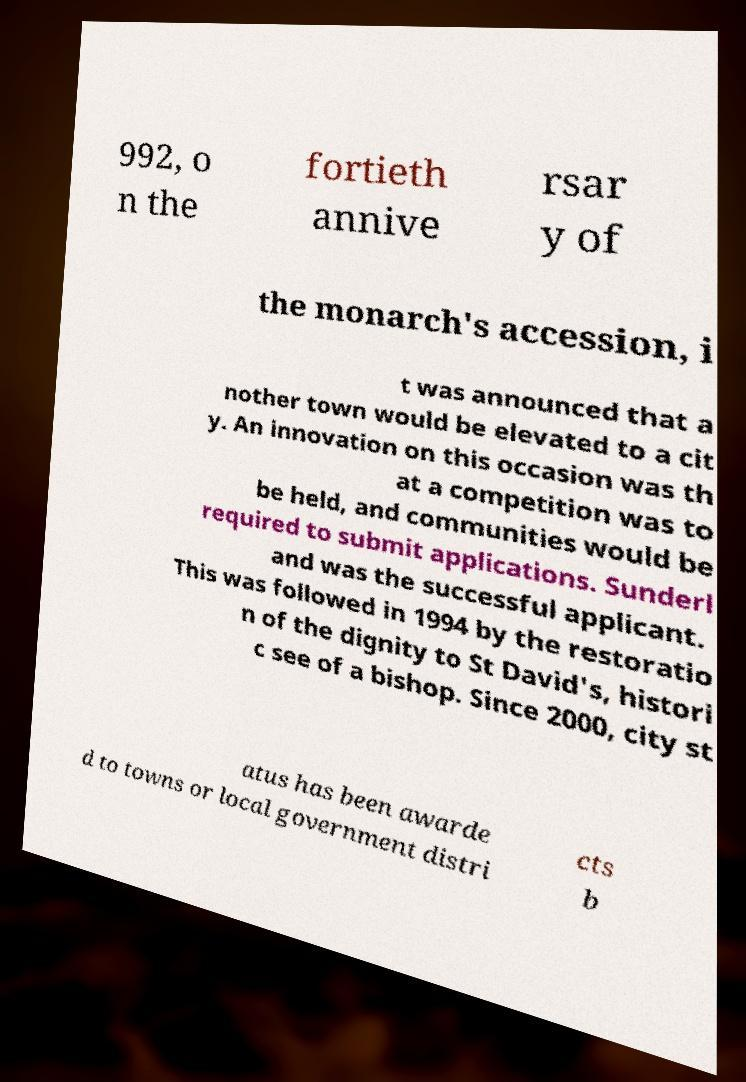Can you read and provide the text displayed in the image?This photo seems to have some interesting text. Can you extract and type it out for me? 992, o n the fortieth annive rsar y of the monarch's accession, i t was announced that a nother town would be elevated to a cit y. An innovation on this occasion was th at a competition was to be held, and communities would be required to submit applications. Sunderl and was the successful applicant. This was followed in 1994 by the restoratio n of the dignity to St David's, histori c see of a bishop. Since 2000, city st atus has been awarde d to towns or local government distri cts b 